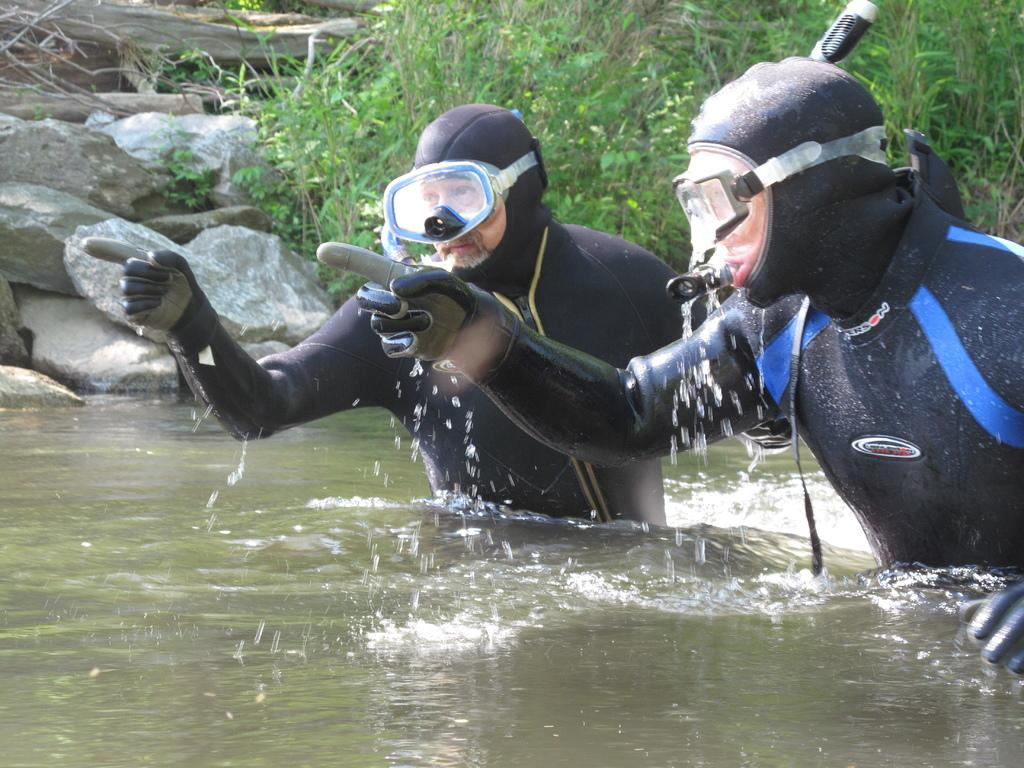How many people are in the water in the image? There are 2 people in the water in the image. What are the people wearing while in the water? The people are wearing scuba dress. What can be seen in the background of the image? There are plants and rocks in the background. What type of lace can be seen on the people's scuba dress in the image? There is no lace visible on the people's scuba dress in the image. What is the taste of the water in the image? The taste of the water cannot be determined from the image. 